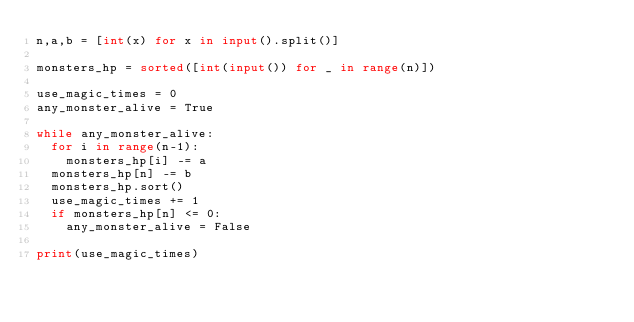<code> <loc_0><loc_0><loc_500><loc_500><_Python_>n,a,b = [int(x) for x in input().split()]

monsters_hp = sorted([int(input()) for _ in range(n)])

use_magic_times = 0
any_monster_alive = True

while any_monster_alive:
	for i in range(n-1):
		monsters_hp[i] -= a
	monsters_hp[n] -= b
	monsters_hp.sort()
	use_magic_times += 1
	if monsters_hp[n] <= 0:
		any_monster_alive = False

print(use_magic_times)</code> 